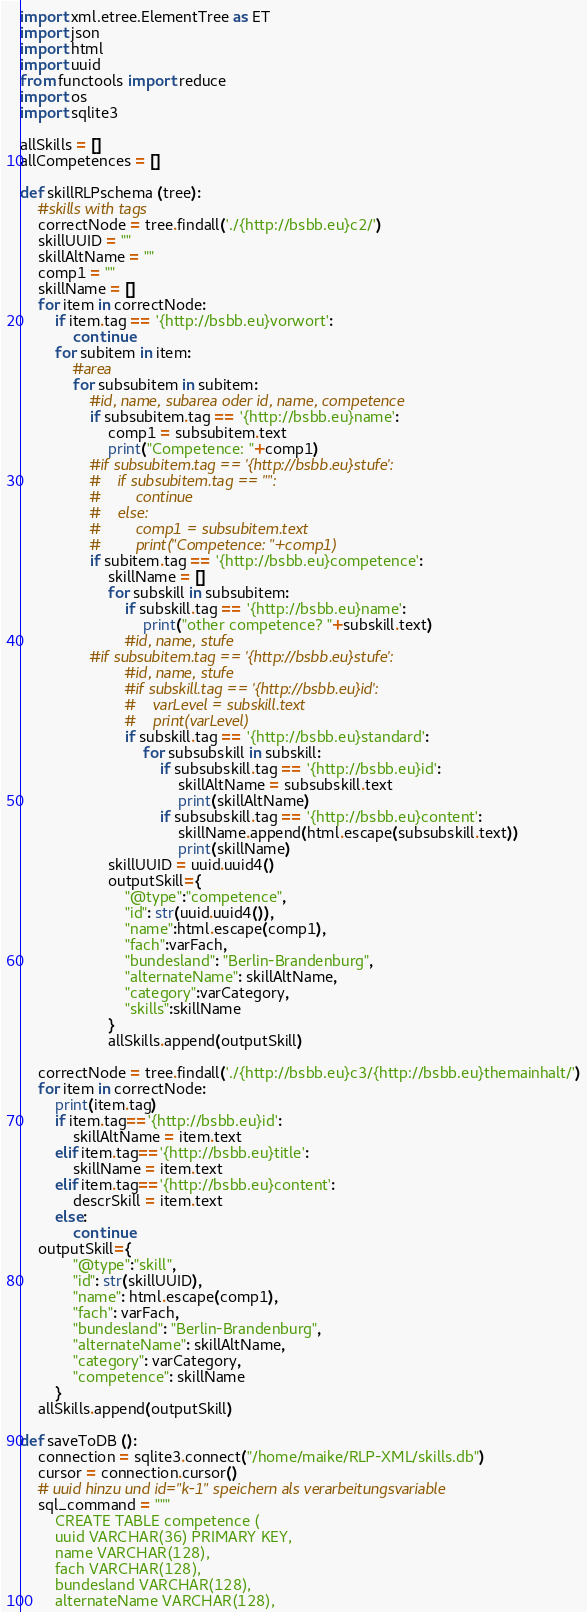Convert code to text. <code><loc_0><loc_0><loc_500><loc_500><_Python_>import xml.etree.ElementTree as ET
import json
import html
import uuid
from functools import reduce
import os
import sqlite3

allSkills = []
allCompetences = []

def skillRLPschema (tree):
    #skills with tags
    correctNode = tree.findall('./{http://bsbb.eu}c2/')
    skillUUID = ""
    skillAltName = ""
    comp1 = ""
    skillName = []
    for item in correctNode:
        if item.tag == '{http://bsbb.eu}vorwort':
            continue
        for subitem in item:
            #area
            for subsubitem in subitem:
                #id, name, subarea oder id, name, competence
                if subsubitem.tag == '{http://bsbb.eu}name':
                    comp1 = subsubitem.text
                    print("Competence: "+comp1)
                #if subsubitem.tag == '{http://bsbb.eu}stufe':
                #    if subsubitem.tag == "":
                #        continue
                #    else:
                #        comp1 = subsubitem.text
                #        print("Competence: "+comp1)
                if subitem.tag == '{http://bsbb.eu}competence':
                    skillName = []
                    for subskill in subsubitem:
                        if subskill.tag == '{http://bsbb.eu}name':
                            print("other competence? "+subskill.text)
                        #id, name, stufe
                #if subsubitem.tag == '{http://bsbb.eu}stufe':
                        #id, name, stufe
                        #if subskill.tag == '{http://bsbb.eu}id':
                        #    varLevel = subskill.text
                        #    print(varLevel)
                        if subskill.tag == '{http://bsbb.eu}standard':
                            for subsubskill in subskill:
                                if subsubskill.tag == '{http://bsbb.eu}id':
                                    skillAltName = subsubskill.text
                                    print(skillAltName)
                                if subsubskill.tag == '{http://bsbb.eu}content':
                                    skillName.append(html.escape(subsubskill.text))
                                    print(skillName)
                    skillUUID = uuid.uuid4()
                    outputSkill={
                        "@type":"competence",
                        "id": str(uuid.uuid4()),
                        "name":html.escape(comp1),
                        "fach":varFach,
                        "bundesland": "Berlin-Brandenburg",
                        "alternateName": skillAltName,
                        "category":varCategory,
                        "skills":skillName
                    }
                    allSkills.append(outputSkill)
    
    correctNode = tree.findall('./{http://bsbb.eu}c3/{http://bsbb.eu}themainhalt/')
    for item in correctNode:
        print(item.tag)
        if item.tag=='{http://bsbb.eu}id':
            skillAltName = item.text
        elif item.tag=='{http://bsbb.eu}title':
            skillName = item.text
        elif item.tag=='{http://bsbb.eu}content':
            descrSkill = item.text
        else:
            continue
    outputSkill={
            "@type":"skill",
            "id": str(skillUUID),
            "name": html.escape(comp1),
            "fach": varFach,
            "bundesland": "Berlin-Brandenburg",
            "alternateName": skillAltName,
            "category": varCategory,
            "competence": skillName
        }
    allSkills.append(outputSkill)

def saveToDB ():
    connection = sqlite3.connect("/home/maike/RLP-XML/skills.db")
    cursor = connection.cursor()
    # uuid hinzu und id="k-1" speichern als verarbeitungsvariable
    sql_command = """
        CREATE TABLE competence ( 
        uuid VARCHAR(36) PRIMARY KEY,
        name VARCHAR(128),
        fach VARCHAR(128),
        bundesland VARCHAR(128),
        alternateName VARCHAR(128),</code> 